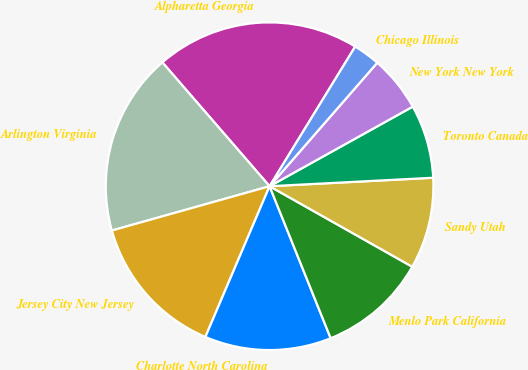<chart> <loc_0><loc_0><loc_500><loc_500><pie_chart><fcel>Alpharetta Georgia<fcel>Arlington Virginia<fcel>Jersey City New Jersey<fcel>Charlotte North Carolina<fcel>Menlo Park California<fcel>Sandy Utah<fcel>Toronto Canada<fcel>New York New York<fcel>Chicago Illinois<nl><fcel>20.11%<fcel>18.0%<fcel>14.23%<fcel>12.49%<fcel>10.74%<fcel>9.0%<fcel>7.25%<fcel>5.51%<fcel>2.66%<nl></chart> 